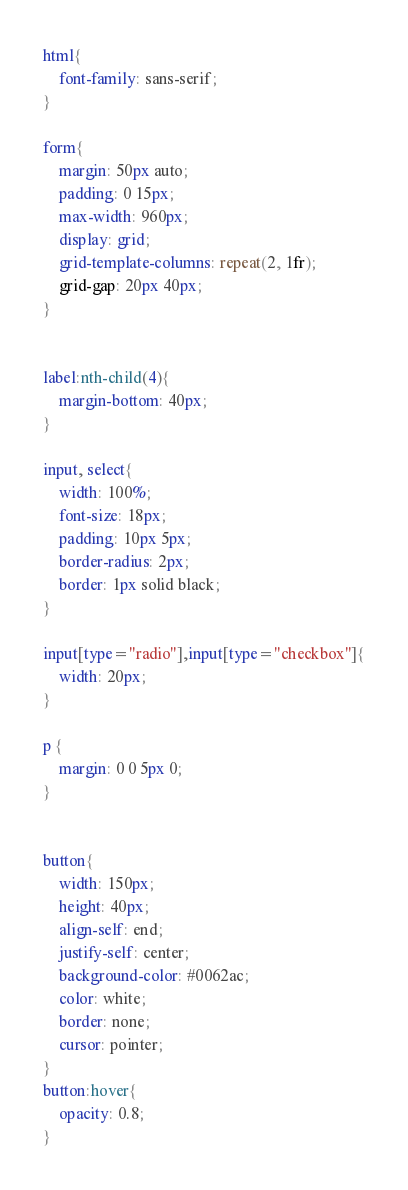<code> <loc_0><loc_0><loc_500><loc_500><_CSS_>html{
    font-family: sans-serif;
}

form{
    margin: 50px auto;
    padding: 0 15px;
    max-width: 960px;
    display: grid;
    grid-template-columns: repeat(2, 1fr);
    grid-gap: 20px 40px;
}


label:nth-child(4){
    margin-bottom: 40px;
}

input, select{
    width: 100%;
    font-size: 18px;
    padding: 10px 5px;
    border-radius: 2px;
    border: 1px solid black;
}

input[type="radio"],input[type="checkbox"]{
    width: 20px;
}

p {
    margin: 0 0 5px 0;
}


button{
    width: 150px;
    height: 40px;
    align-self: end;
    justify-self: center;
    background-color: #0062ac;
    color: white;
    border: none;
    cursor: pointer;
}
button:hover{
    opacity: 0.8;
}</code> 